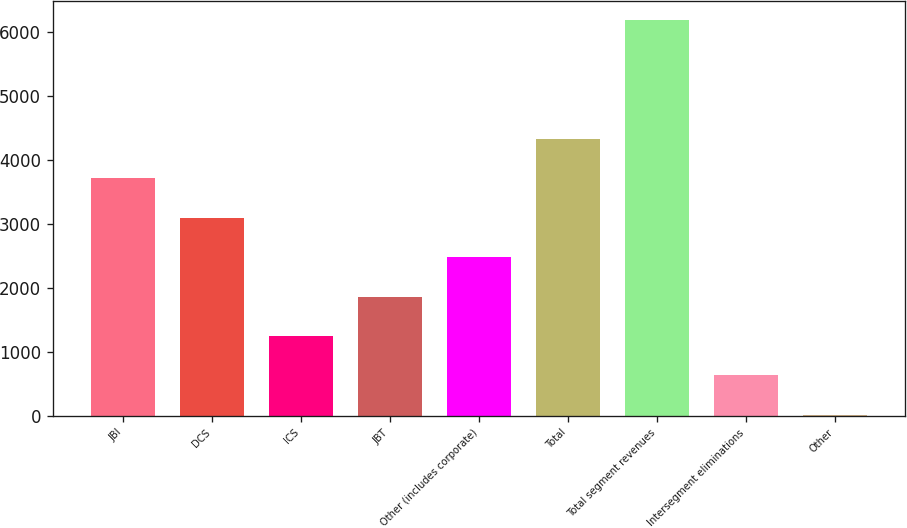Convert chart. <chart><loc_0><loc_0><loc_500><loc_500><bar_chart><fcel>JBI<fcel>DCS<fcel>ICS<fcel>JBT<fcel>Other (includes corporate)<fcel>Total<fcel>Total segment revenues<fcel>Intersegment eliminations<fcel>Other<nl><fcel>3717<fcel>3100<fcel>1249<fcel>1866<fcel>2483<fcel>4334<fcel>6185<fcel>632<fcel>15<nl></chart> 